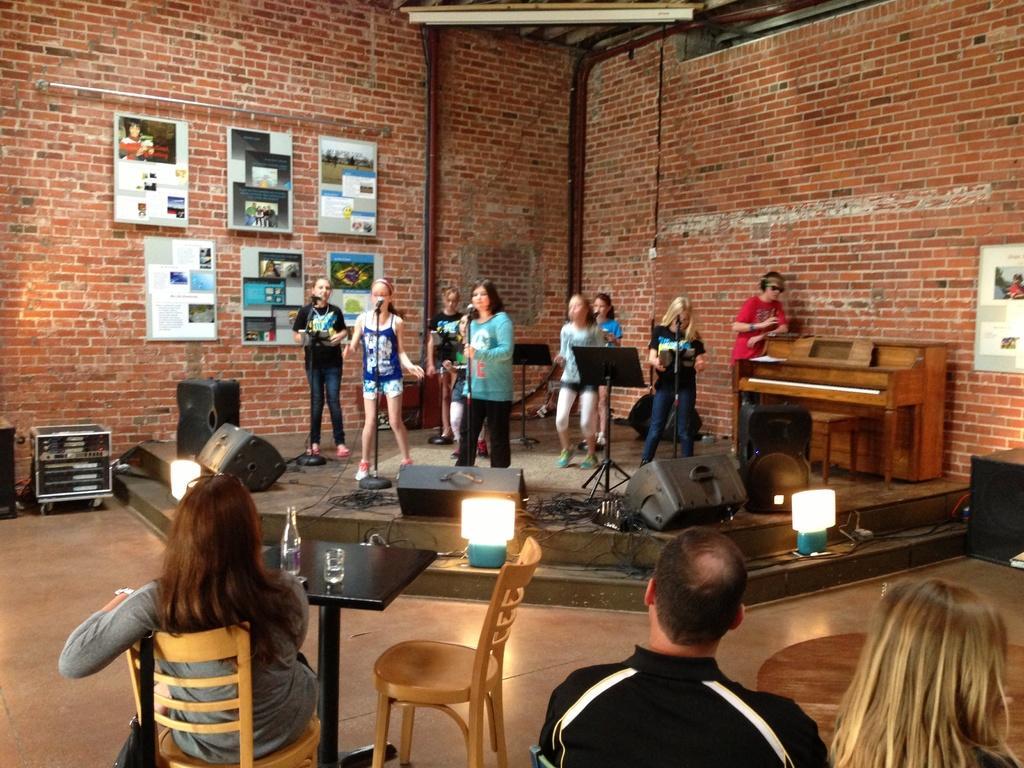Please provide a concise description of this image. As we can see in the image there are people who are sitting on the chairs and in front of them there are table on which there is a glass and bottle in front of them there is a stage on which girls are performing and the man who is standing he is wearing headphones. Behind them there is a wall which is of red bricks and on the wall there are photo frames kept. On the stage there are speakers, lights, wires and mike, mike stand and a piano. 